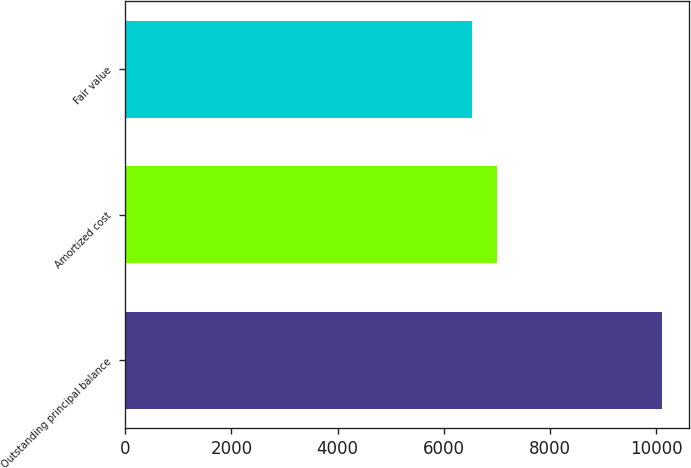Convert chart. <chart><loc_0><loc_0><loc_500><loc_500><bar_chart><fcel>Outstanding principal balance<fcel>Amortized cost<fcel>Fair value<nl><fcel>10119<fcel>7006<fcel>6535<nl></chart> 